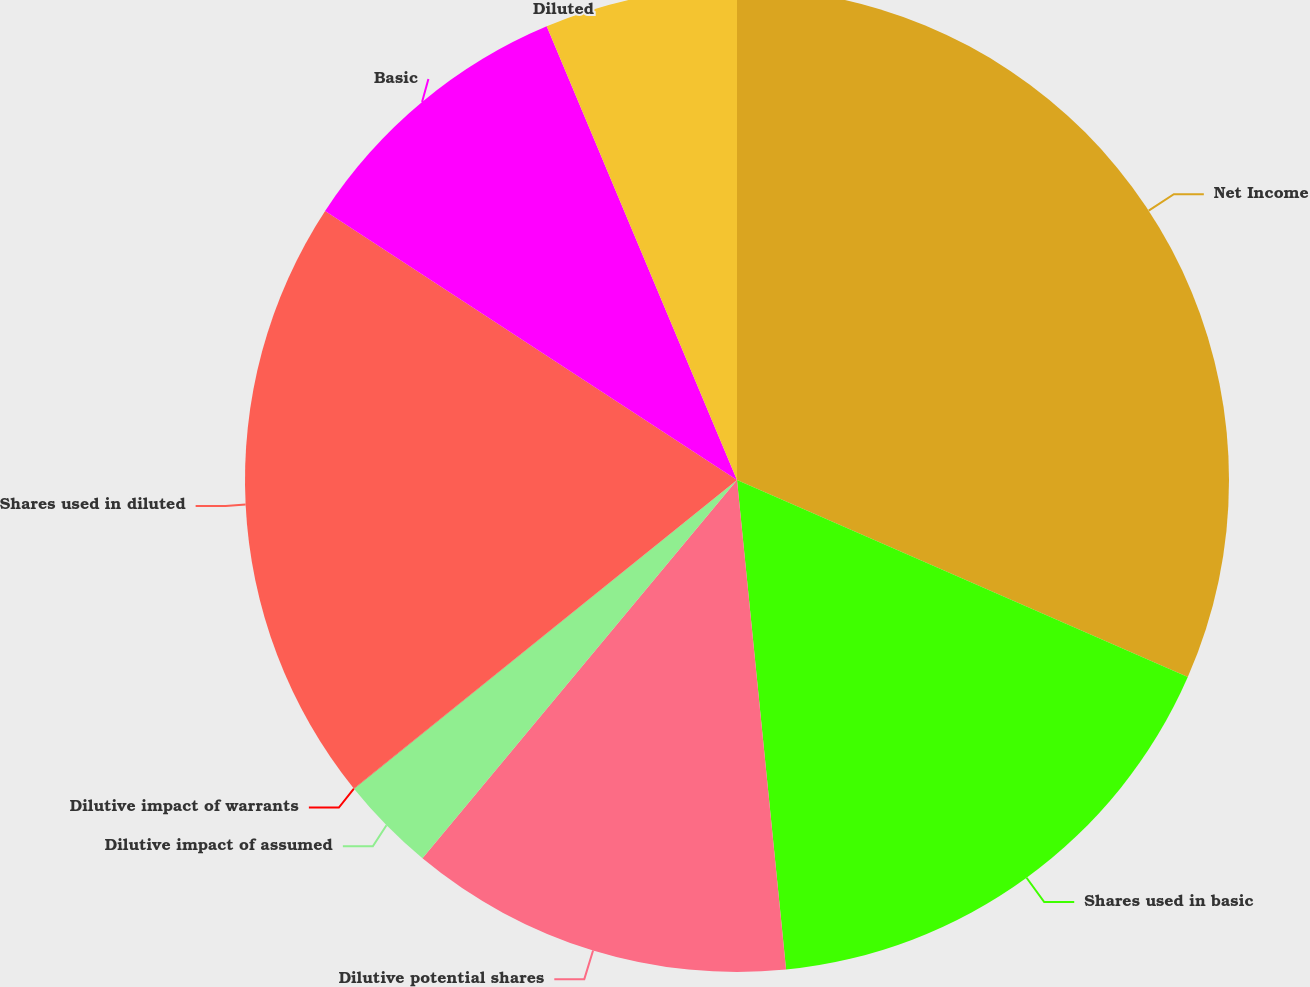Convert chart to OTSL. <chart><loc_0><loc_0><loc_500><loc_500><pie_chart><fcel>Net Income<fcel>Shares used in basic<fcel>Dilutive potential shares<fcel>Dilutive impact of assumed<fcel>Dilutive impact of warrants<fcel>Shares used in diluted<fcel>Basic<fcel>Diluted<nl><fcel>31.56%<fcel>16.85%<fcel>12.63%<fcel>3.16%<fcel>0.01%<fcel>20.0%<fcel>9.47%<fcel>6.32%<nl></chart> 